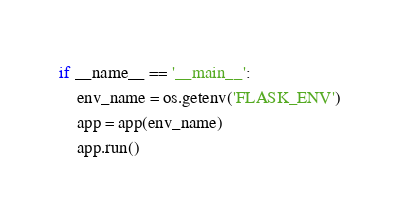Convert code to text. <code><loc_0><loc_0><loc_500><loc_500><_Python_>if __name__ == '__main__':
    env_name = os.getenv('FLASK_ENV')
    app = app(env_name)
    app.run()
</code> 